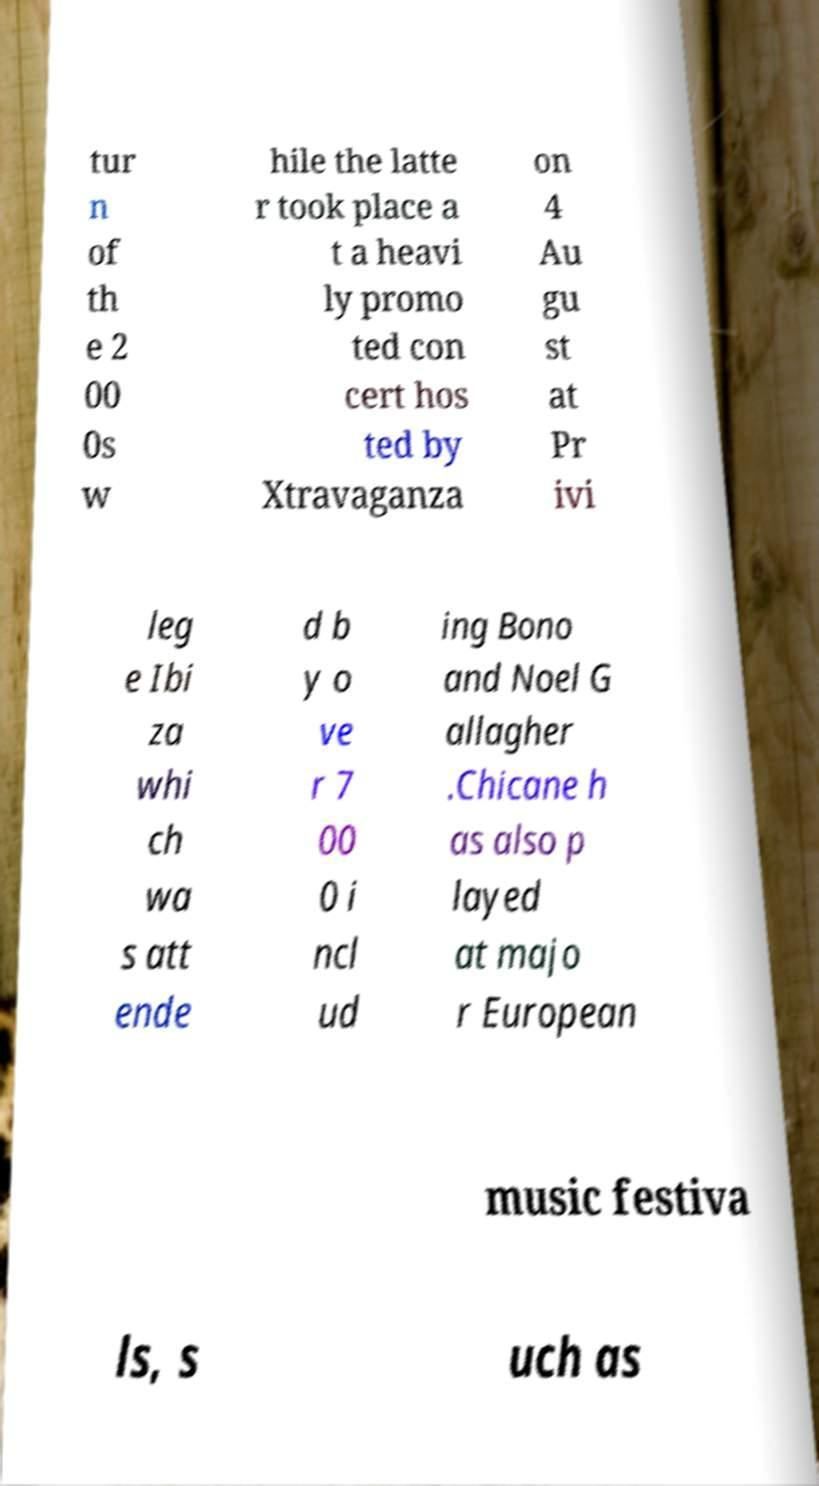Could you extract and type out the text from this image? tur n of th e 2 00 0s w hile the latte r took place a t a heavi ly promo ted con cert hos ted by Xtravaganza on 4 Au gu st at Pr ivi leg e Ibi za whi ch wa s att ende d b y o ve r 7 00 0 i ncl ud ing Bono and Noel G allagher .Chicane h as also p layed at majo r European music festiva ls, s uch as 